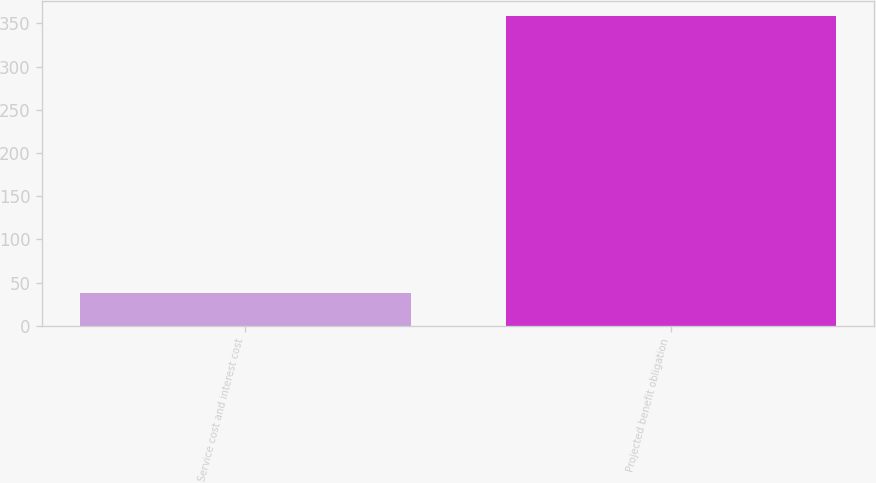<chart> <loc_0><loc_0><loc_500><loc_500><bar_chart><fcel>Service cost and interest cost<fcel>Projected benefit obligation<nl><fcel>38<fcel>358<nl></chart> 